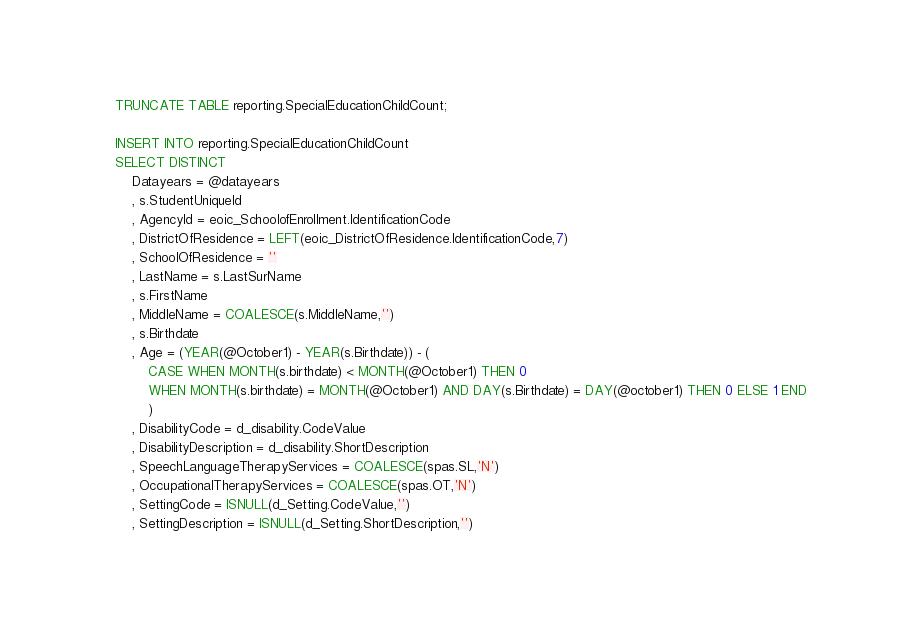<code> <loc_0><loc_0><loc_500><loc_500><_SQL_>
    TRUNCATE TABLE reporting.SpecialEducationChildCount;

    INSERT INTO reporting.SpecialEducationChildCount
    SELECT DISTINCT
        Datayears = @datayears
        , s.StudentUniqueId
        , AgencyId = eoic_SchoolofEnrollment.IdentificationCode
        , DistrictOfResidence = LEFT(eoic_DistrictOfResidence.IdentificationCode,7)
        , SchoolOfResidence = ''
        , LastName = s.LastSurName
        , s.FirstName
        , MiddleName = COALESCE(s.MiddleName,'')
        , s.Birthdate
        , Age = (YEAR(@October1) - YEAR(s.Birthdate)) - (
            CASE WHEN MONTH(s.birthdate) < MONTH(@October1) THEN 0
            WHEN MONTH(s.birthdate) = MONTH(@October1) AND DAY(s.Birthdate) = DAY(@october1) THEN 0 ELSE 1 END
            )
        , DisabilityCode = d_disability.CodeValue
        , DisabilityDescription = d_disability.ShortDescription
        , SpeechLanguageTherapyServices = COALESCE(spas.SL,'N')
        , OccupationalTherapyServices = COALESCE(spas.OT,'N')
        , SettingCode = ISNULL(d_Setting.CodeValue,'')
        , SettingDescription = ISNULL(d_Setting.ShortDescription,'')</code> 